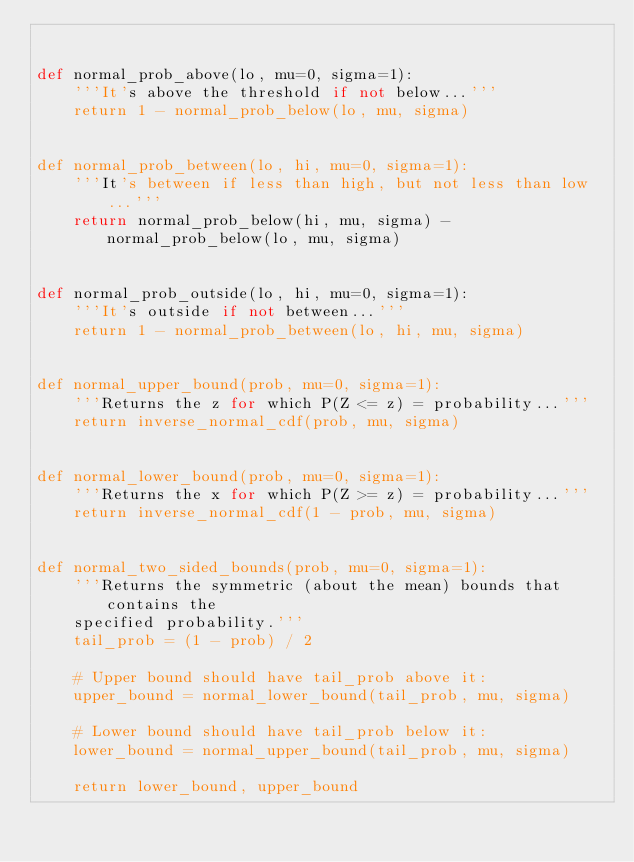<code> <loc_0><loc_0><loc_500><loc_500><_Python_>

def normal_prob_above(lo, mu=0, sigma=1):
    '''It's above the threshold if not below...'''
    return 1 - normal_prob_below(lo, mu, sigma)


def normal_prob_between(lo, hi, mu=0, sigma=1):
    '''It's between if less than high, but not less than low...'''
    return normal_prob_below(hi, mu, sigma) - normal_prob_below(lo, mu, sigma)


def normal_prob_outside(lo, hi, mu=0, sigma=1):
    '''It's outside if not between...'''
    return 1 - normal_prob_between(lo, hi, mu, sigma)


def normal_upper_bound(prob, mu=0, sigma=1):
    '''Returns the z for which P(Z <= z) = probability...'''
    return inverse_normal_cdf(prob, mu, sigma)


def normal_lower_bound(prob, mu=0, sigma=1):
    '''Returns the x for which P(Z >= z) = probability...'''
    return inverse_normal_cdf(1 - prob, mu, sigma)


def normal_two_sided_bounds(prob, mu=0, sigma=1):
    '''Returns the symmetric (about the mean) bounds that contains the
    specified probability.'''
    tail_prob = (1 - prob) / 2

    # Upper bound should have tail_prob above it:
    upper_bound = normal_lower_bound(tail_prob, mu, sigma)

    # Lower bound should have tail_prob below it:
    lower_bound = normal_upper_bound(tail_prob, mu, sigma)

    return lower_bound, upper_bound

</code> 